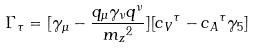<formula> <loc_0><loc_0><loc_500><loc_500>\Gamma _ { \tau } = [ { \gamma _ { \mu } } - \frac { { q _ { \mu } } { \gamma _ { \nu } } { q ^ { \nu } } } { { m _ { z } } ^ { 2 } } ] [ { c _ { V } } ^ { \tau } - { c _ { A } } ^ { \tau } { \gamma _ { 5 } } ]</formula> 